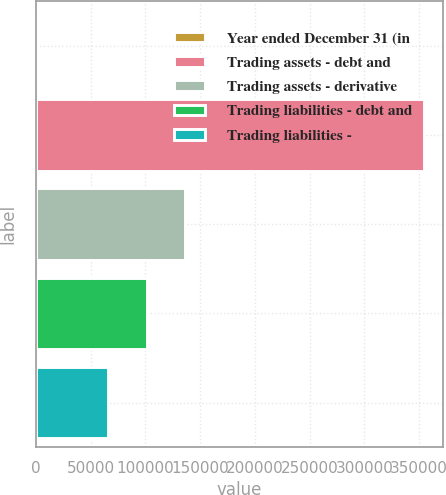Convert chart to OTSL. <chart><loc_0><loc_0><loc_500><loc_500><bar_chart><fcel>Year ended December 31 (in<fcel>Trading assets - debt and<fcel>Trading assets - derivative<fcel>Trading liabilities - debt and<fcel>Trading liabilities -<nl><fcel>2010<fcel>354441<fcel>136200<fcel>100957<fcel>65714<nl></chart> 